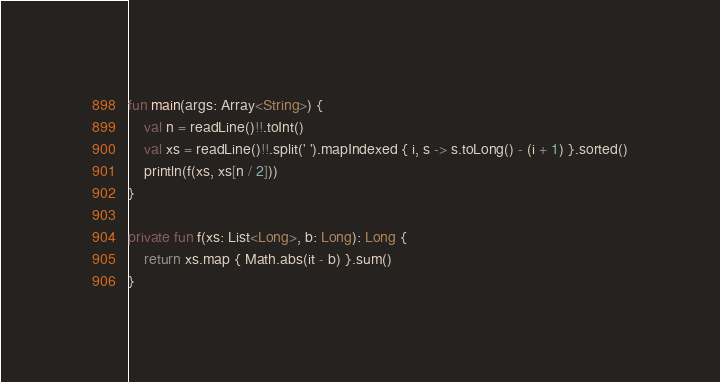<code> <loc_0><loc_0><loc_500><loc_500><_Kotlin_>fun main(args: Array<String>) {
    val n = readLine()!!.toInt()
    val xs = readLine()!!.split(' ').mapIndexed { i, s -> s.toLong() - (i + 1) }.sorted()
    println(f(xs, xs[n / 2]))
}

private fun f(xs: List<Long>, b: Long): Long {
    return xs.map { Math.abs(it - b) }.sum()
}</code> 